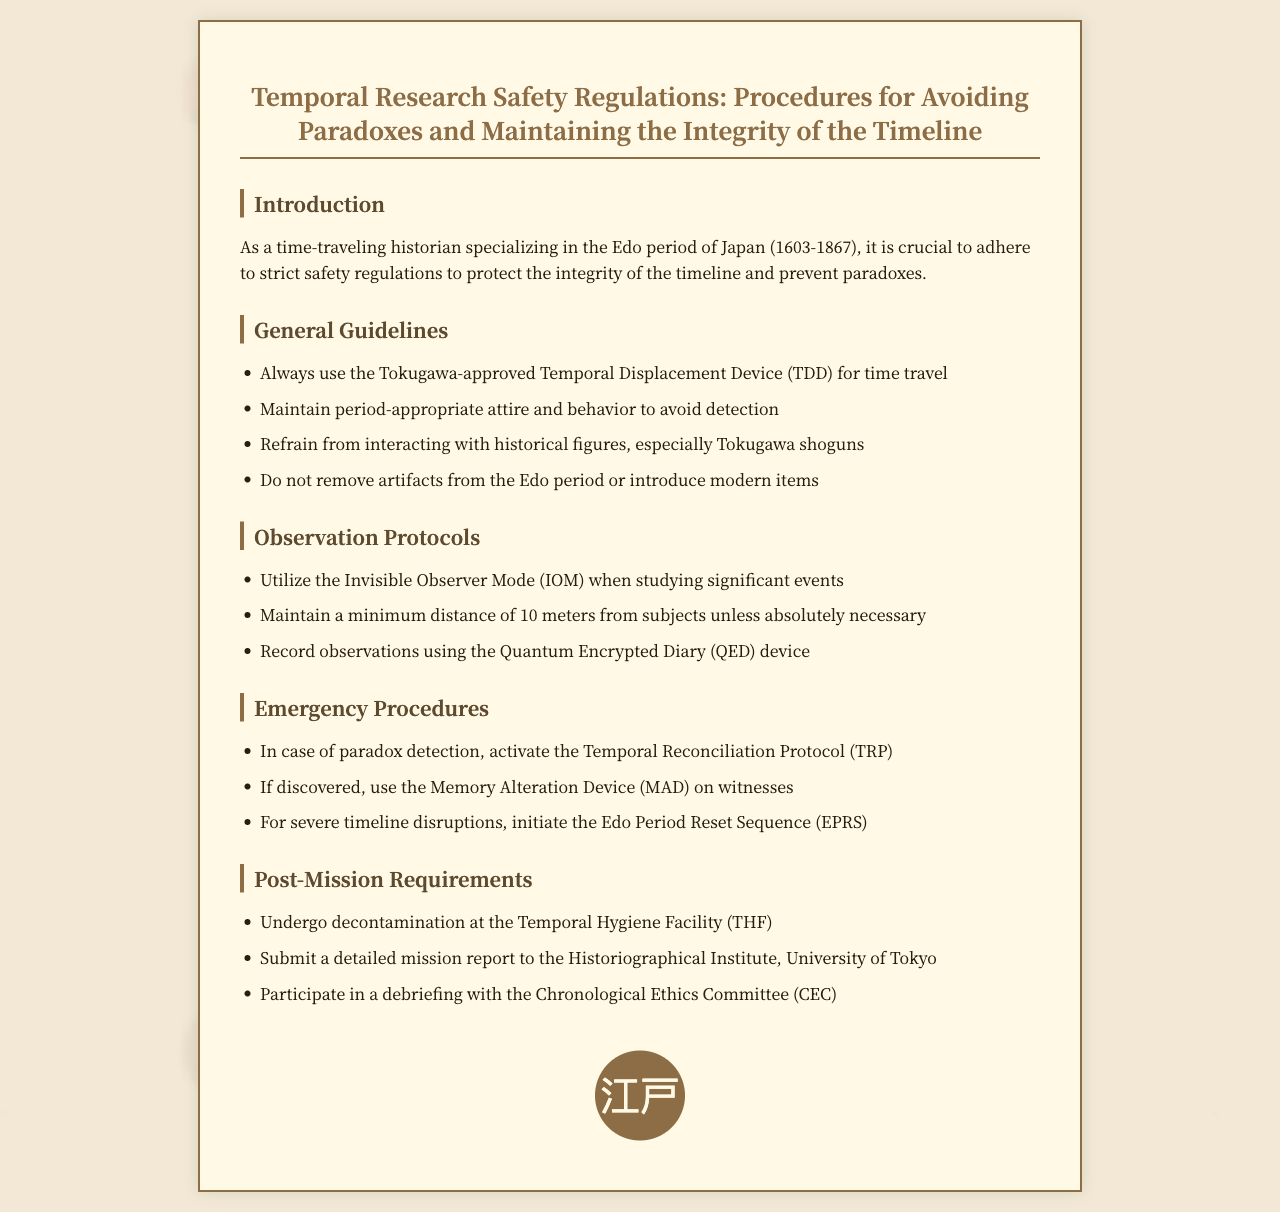what is the title of the document? The title of the document is prominently displayed at the top and reads "Temporal Research Safety Regulations: Procedures for Avoiding Paradoxes and Maintaining the Integrity of the Timeline."
Answer: Temporal Research Safety Regulations: Procedures for Avoiding Paradoxes and Maintaining the Integrity of the Timeline what is the minimum distance to maintain from subjects? The guideline specifies a minimum distance that should be maintained from subjects unless absolutely necessary.
Answer: 10 meters what device is approved for time travel? The document mentions the device that must be used for time travel.
Answer: Tokugawa-approved Temporal Displacement Device (TDD) what should be submitted after a mission? The document stipulates what should be done post-mission.
Answer: A detailed mission report to the Historiographical Institute, University of Tokyo what does TRP stand for? The acronym TRP is used in the emergency procedures section of the document, which is an essential part of handling paradox detection.
Answer: Temporal Reconciliation Protocol what is the purpose of the Memory Alteration Device? This device is referenced in the emergency procedures section of the document and serves a specific purpose when a time traveler is discovered.
Answer: To alter witnesses' memories how many emergency procedures are listed? The number of emergency procedures mentioned in the document is a specific data point that can be counted.
Answer: Three what is the focus of the introduction section? The introduction outlines the importance of adhering to regulations for a specific purpose in time travel.
Answer: Protect the integrity of the timeline and prevent paradoxes what does the seal symbolize? The seal displayed at the end of the document features a specific text that relates to the Edo period.
Answer: Edo 